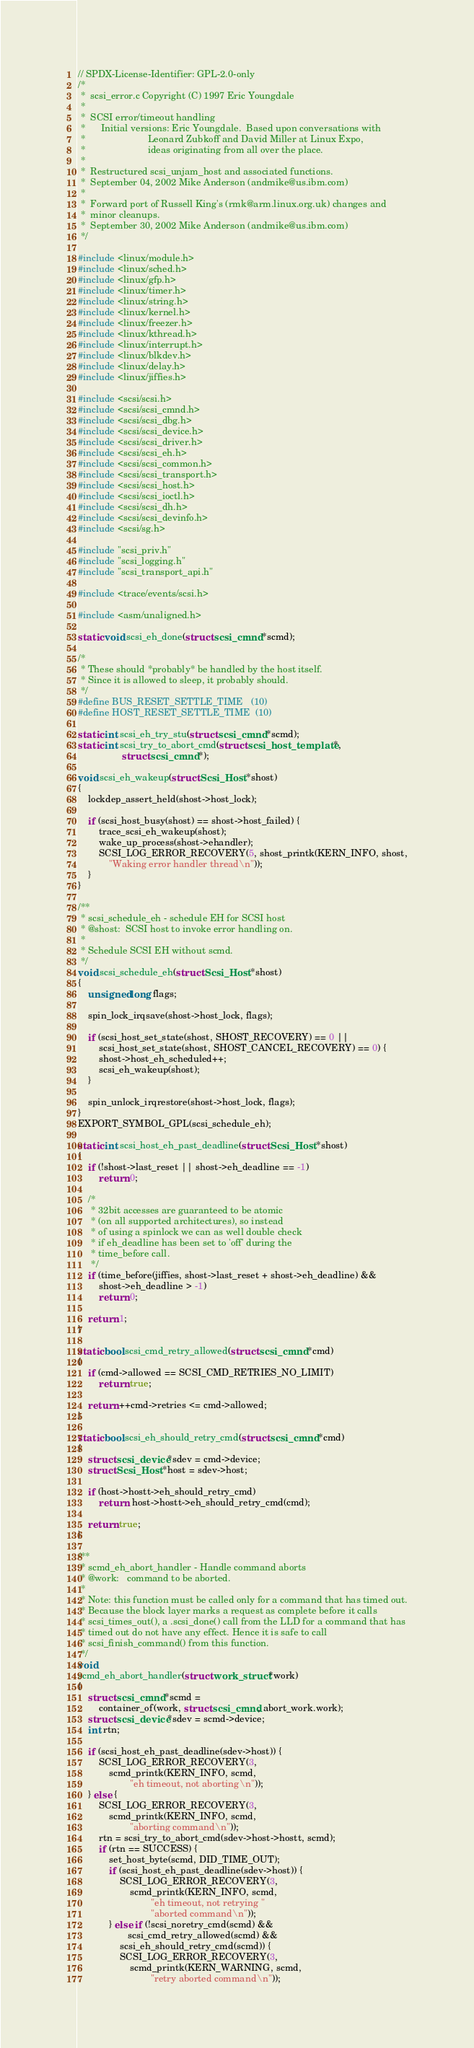Convert code to text. <code><loc_0><loc_0><loc_500><loc_500><_C_>// SPDX-License-Identifier: GPL-2.0-only
/*
 *  scsi_error.c Copyright (C) 1997 Eric Youngdale
 *
 *  SCSI error/timeout handling
 *      Initial versions: Eric Youngdale.  Based upon conversations with
 *                        Leonard Zubkoff and David Miller at Linux Expo,
 *                        ideas originating from all over the place.
 *
 *	Restructured scsi_unjam_host and associated functions.
 *	September 04, 2002 Mike Anderson (andmike@us.ibm.com)
 *
 *	Forward port of Russell King's (rmk@arm.linux.org.uk) changes and
 *	minor cleanups.
 *	September 30, 2002 Mike Anderson (andmike@us.ibm.com)
 */

#include <linux/module.h>
#include <linux/sched.h>
#include <linux/gfp.h>
#include <linux/timer.h>
#include <linux/string.h>
#include <linux/kernel.h>
#include <linux/freezer.h>
#include <linux/kthread.h>
#include <linux/interrupt.h>
#include <linux/blkdev.h>
#include <linux/delay.h>
#include <linux/jiffies.h>

#include <scsi/scsi.h>
#include <scsi/scsi_cmnd.h>
#include <scsi/scsi_dbg.h>
#include <scsi/scsi_device.h>
#include <scsi/scsi_driver.h>
#include <scsi/scsi_eh.h>
#include <scsi/scsi_common.h>
#include <scsi/scsi_transport.h>
#include <scsi/scsi_host.h>
#include <scsi/scsi_ioctl.h>
#include <scsi/scsi_dh.h>
#include <scsi/scsi_devinfo.h>
#include <scsi/sg.h>

#include "scsi_priv.h"
#include "scsi_logging.h"
#include "scsi_transport_api.h"

#include <trace/events/scsi.h>

#include <asm/unaligned.h>

static void scsi_eh_done(struct scsi_cmnd *scmd);

/*
 * These should *probably* be handled by the host itself.
 * Since it is allowed to sleep, it probably should.
 */
#define BUS_RESET_SETTLE_TIME   (10)
#define HOST_RESET_SETTLE_TIME  (10)

static int scsi_eh_try_stu(struct scsi_cmnd *scmd);
static int scsi_try_to_abort_cmd(struct scsi_host_template *,
				 struct scsi_cmnd *);

void scsi_eh_wakeup(struct Scsi_Host *shost)
{
	lockdep_assert_held(shost->host_lock);

	if (scsi_host_busy(shost) == shost->host_failed) {
		trace_scsi_eh_wakeup(shost);
		wake_up_process(shost->ehandler);
		SCSI_LOG_ERROR_RECOVERY(5, shost_printk(KERN_INFO, shost,
			"Waking error handler thread\n"));
	}
}

/**
 * scsi_schedule_eh - schedule EH for SCSI host
 * @shost:	SCSI host to invoke error handling on.
 *
 * Schedule SCSI EH without scmd.
 */
void scsi_schedule_eh(struct Scsi_Host *shost)
{
	unsigned long flags;

	spin_lock_irqsave(shost->host_lock, flags);

	if (scsi_host_set_state(shost, SHOST_RECOVERY) == 0 ||
	    scsi_host_set_state(shost, SHOST_CANCEL_RECOVERY) == 0) {
		shost->host_eh_scheduled++;
		scsi_eh_wakeup(shost);
	}

	spin_unlock_irqrestore(shost->host_lock, flags);
}
EXPORT_SYMBOL_GPL(scsi_schedule_eh);

static int scsi_host_eh_past_deadline(struct Scsi_Host *shost)
{
	if (!shost->last_reset || shost->eh_deadline == -1)
		return 0;

	/*
	 * 32bit accesses are guaranteed to be atomic
	 * (on all supported architectures), so instead
	 * of using a spinlock we can as well double check
	 * if eh_deadline has been set to 'off' during the
	 * time_before call.
	 */
	if (time_before(jiffies, shost->last_reset + shost->eh_deadline) &&
	    shost->eh_deadline > -1)
		return 0;

	return 1;
}

static bool scsi_cmd_retry_allowed(struct scsi_cmnd *cmd)
{
	if (cmd->allowed == SCSI_CMD_RETRIES_NO_LIMIT)
		return true;

	return ++cmd->retries <= cmd->allowed;
}

static bool scsi_eh_should_retry_cmd(struct scsi_cmnd *cmd)
{
	struct scsi_device *sdev = cmd->device;
	struct Scsi_Host *host = sdev->host;

	if (host->hostt->eh_should_retry_cmd)
		return  host->hostt->eh_should_retry_cmd(cmd);

	return true;
}

/**
 * scmd_eh_abort_handler - Handle command aborts
 * @work:	command to be aborted.
 *
 * Note: this function must be called only for a command that has timed out.
 * Because the block layer marks a request as complete before it calls
 * scsi_times_out(), a .scsi_done() call from the LLD for a command that has
 * timed out do not have any effect. Hence it is safe to call
 * scsi_finish_command() from this function.
 */
void
scmd_eh_abort_handler(struct work_struct *work)
{
	struct scsi_cmnd *scmd =
		container_of(work, struct scsi_cmnd, abort_work.work);
	struct scsi_device *sdev = scmd->device;
	int rtn;

	if (scsi_host_eh_past_deadline(sdev->host)) {
		SCSI_LOG_ERROR_RECOVERY(3,
			scmd_printk(KERN_INFO, scmd,
				    "eh timeout, not aborting\n"));
	} else {
		SCSI_LOG_ERROR_RECOVERY(3,
			scmd_printk(KERN_INFO, scmd,
				    "aborting command\n"));
		rtn = scsi_try_to_abort_cmd(sdev->host->hostt, scmd);
		if (rtn == SUCCESS) {
			set_host_byte(scmd, DID_TIME_OUT);
			if (scsi_host_eh_past_deadline(sdev->host)) {
				SCSI_LOG_ERROR_RECOVERY(3,
					scmd_printk(KERN_INFO, scmd,
						    "eh timeout, not retrying "
						    "aborted command\n"));
			} else if (!scsi_noretry_cmd(scmd) &&
				   scsi_cmd_retry_allowed(scmd) &&
				scsi_eh_should_retry_cmd(scmd)) {
				SCSI_LOG_ERROR_RECOVERY(3,
					scmd_printk(KERN_WARNING, scmd,
						    "retry aborted command\n"));</code> 